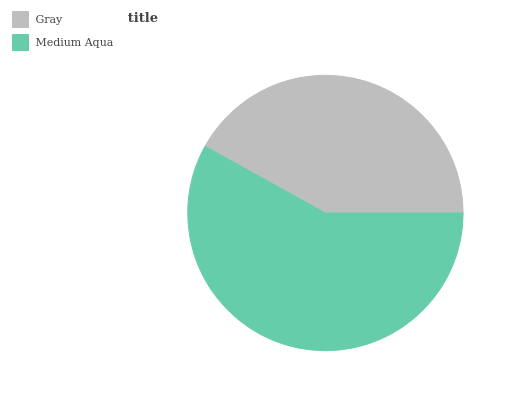Is Gray the minimum?
Answer yes or no. Yes. Is Medium Aqua the maximum?
Answer yes or no. Yes. Is Medium Aqua the minimum?
Answer yes or no. No. Is Medium Aqua greater than Gray?
Answer yes or no. Yes. Is Gray less than Medium Aqua?
Answer yes or no. Yes. Is Gray greater than Medium Aqua?
Answer yes or no. No. Is Medium Aqua less than Gray?
Answer yes or no. No. Is Medium Aqua the high median?
Answer yes or no. Yes. Is Gray the low median?
Answer yes or no. Yes. Is Gray the high median?
Answer yes or no. No. Is Medium Aqua the low median?
Answer yes or no. No. 